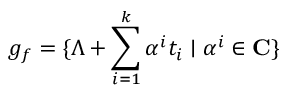<formula> <loc_0><loc_0><loc_500><loc_500>g _ { f } = \{ \Lambda + \sum _ { i = 1 } ^ { k } \alpha ^ { i } t _ { i } | \alpha ^ { i } \in { C } \}</formula> 